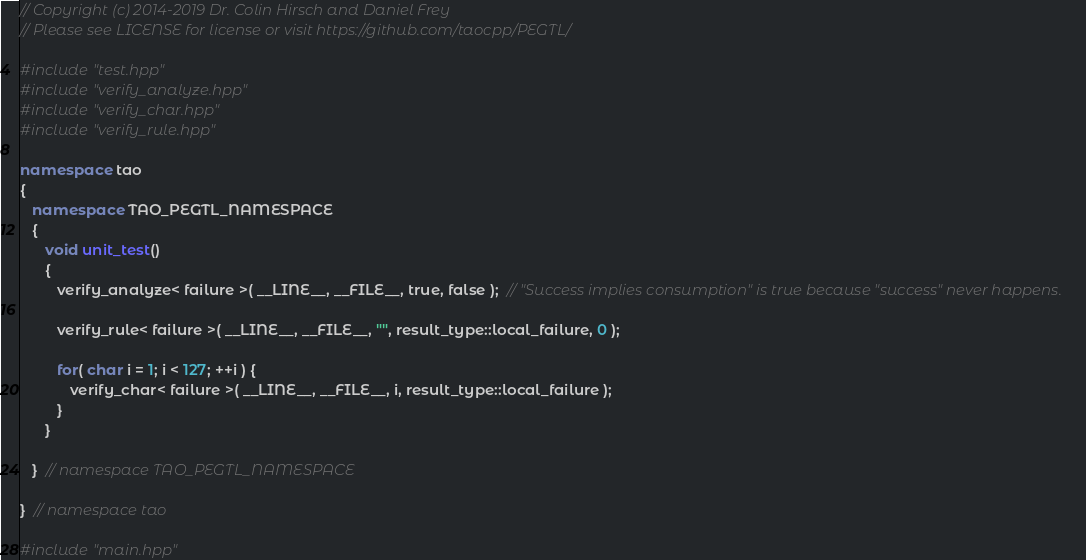<code> <loc_0><loc_0><loc_500><loc_500><_C++_>// Copyright (c) 2014-2019 Dr. Colin Hirsch and Daniel Frey
// Please see LICENSE for license or visit https://github.com/taocpp/PEGTL/

#include "test.hpp"
#include "verify_analyze.hpp"
#include "verify_char.hpp"
#include "verify_rule.hpp"

namespace tao
{
   namespace TAO_PEGTL_NAMESPACE
   {
      void unit_test()
      {
         verify_analyze< failure >( __LINE__, __FILE__, true, false );  // "Success implies consumption" is true because "success" never happens.

         verify_rule< failure >( __LINE__, __FILE__, "", result_type::local_failure, 0 );

         for( char i = 1; i < 127; ++i ) {
            verify_char< failure >( __LINE__, __FILE__, i, result_type::local_failure );
         }
      }

   }  // namespace TAO_PEGTL_NAMESPACE

}  // namespace tao

#include "main.hpp"
</code> 